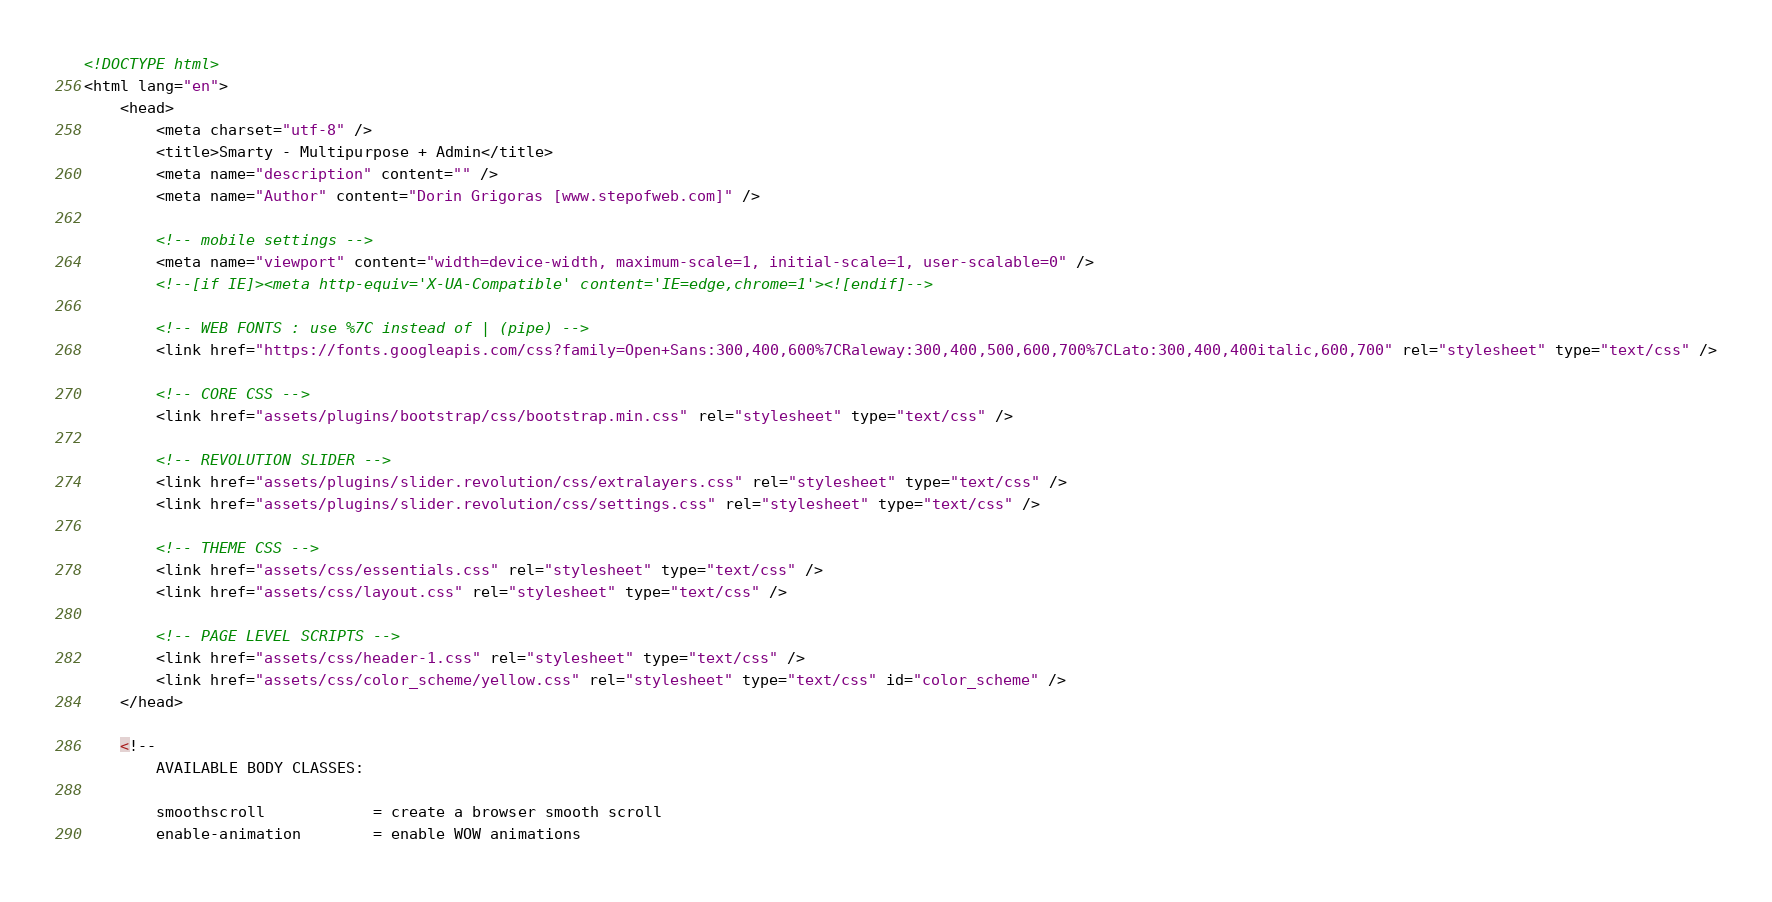Convert code to text. <code><loc_0><loc_0><loc_500><loc_500><_HTML_><!DOCTYPE html>
<html lang="en">
	<head>
		<meta charset="utf-8" />
		<title>Smarty - Multipurpose + Admin</title>
		<meta name="description" content="" />
		<meta name="Author" content="Dorin Grigoras [www.stepofweb.com]" />

		<!-- mobile settings -->
		<meta name="viewport" content="width=device-width, maximum-scale=1, initial-scale=1, user-scalable=0" />
		<!--[if IE]><meta http-equiv='X-UA-Compatible' content='IE=edge,chrome=1'><![endif]-->

		<!-- WEB FONTS : use %7C instead of | (pipe) -->
		<link href="https://fonts.googleapis.com/css?family=Open+Sans:300,400,600%7CRaleway:300,400,500,600,700%7CLato:300,400,400italic,600,700" rel="stylesheet" type="text/css" />

		<!-- CORE CSS -->
		<link href="assets/plugins/bootstrap/css/bootstrap.min.css" rel="stylesheet" type="text/css" />

		<!-- REVOLUTION SLIDER -->
		<link href="assets/plugins/slider.revolution/css/extralayers.css" rel="stylesheet" type="text/css" />
		<link href="assets/plugins/slider.revolution/css/settings.css" rel="stylesheet" type="text/css" />

		<!-- THEME CSS -->
		<link href="assets/css/essentials.css" rel="stylesheet" type="text/css" />
		<link href="assets/css/layout.css" rel="stylesheet" type="text/css" />

		<!-- PAGE LEVEL SCRIPTS -->
		<link href="assets/css/header-1.css" rel="stylesheet" type="text/css" />
		<link href="assets/css/color_scheme/yellow.css" rel="stylesheet" type="text/css" id="color_scheme" />
	</head>

	<!--
		AVAILABLE BODY CLASSES:
		
		smoothscroll 			= create a browser smooth scroll
		enable-animation		= enable WOW animations
</code> 